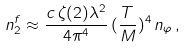Convert formula to latex. <formula><loc_0><loc_0><loc_500><loc_500>n _ { 2 } ^ { f } \approx \frac { c \, \zeta ( 2 ) \lambda ^ { 2 } } { 4 \pi ^ { 4 } } \, ( \frac { T } { M } ) ^ { 4 } \, n _ { \varphi } \, ,</formula> 